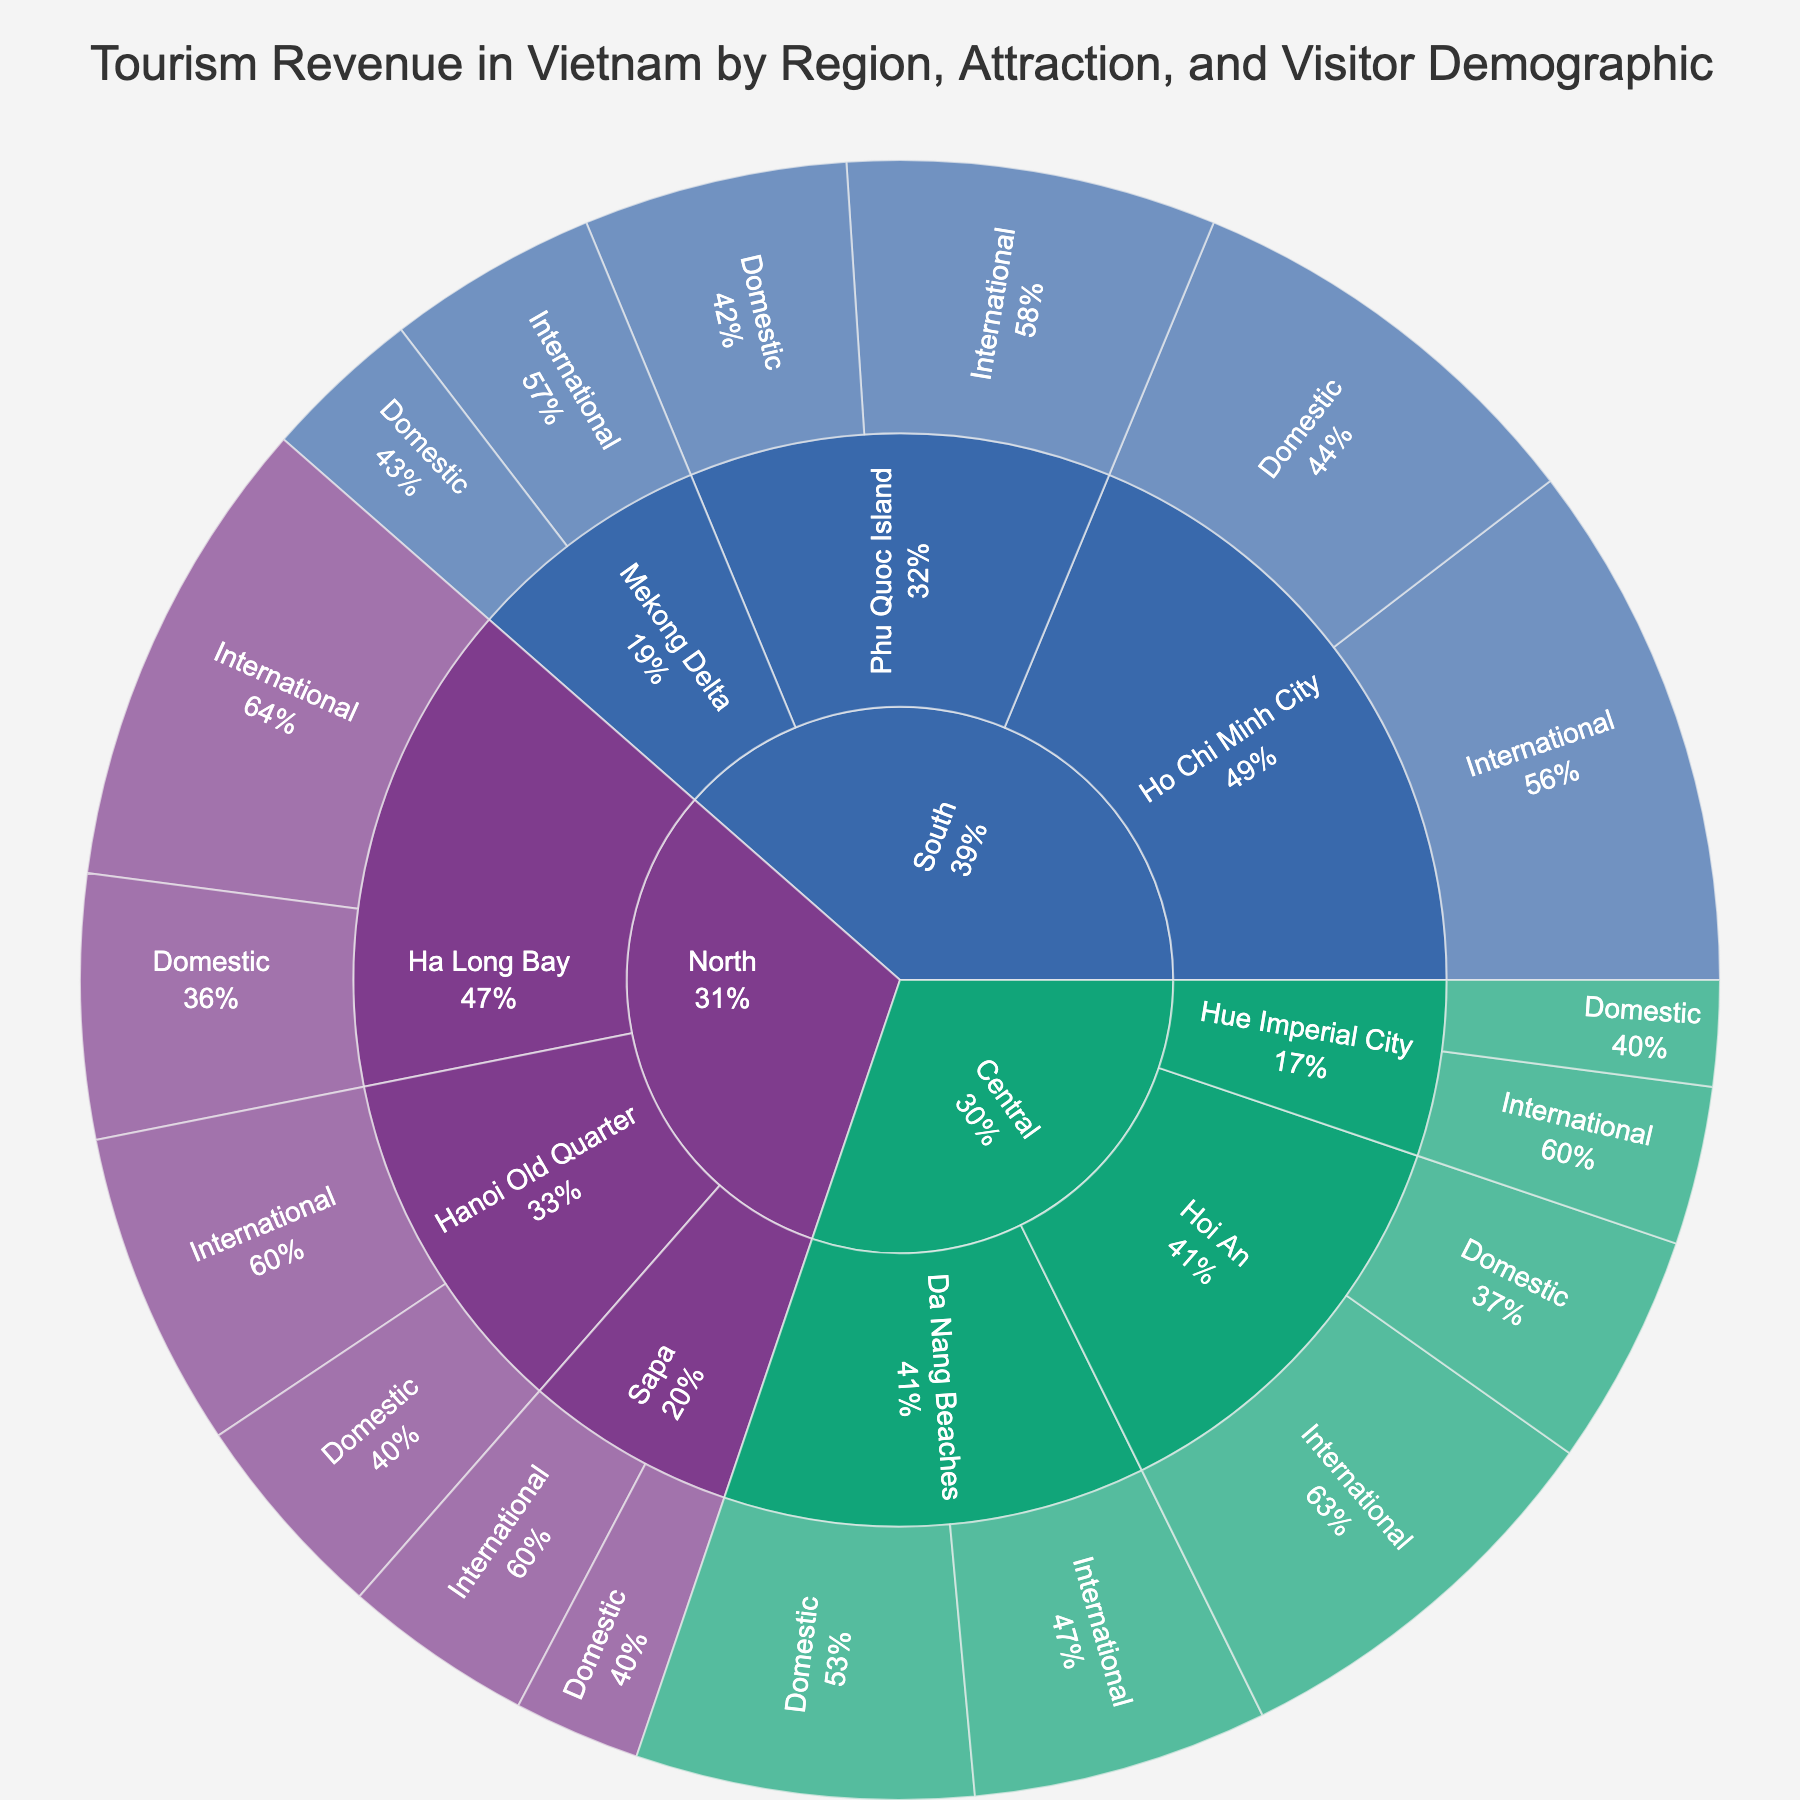what is the total tourism revenue for the North region? Calculate the total revenue for the North region by summing up the revenue from all attractions (International and Domestic visitors) in the North: $450,000,000 + $250,000,000 + $180,000,000 + $120,000,000 + $300,000,000 + $200,000,000 = $1,500,000,000
Answer: $1.5 billion which attraction in the Central region generates the highest revenue? Identify the attraction in the Central region with the highest combined revenue from both International and Domestic visitors. Hoi An has $380,000,000 (International) + $220,000,000 (Domestic) combined, Da Nang Beaches has $280,000,000 + $320,000,000, so Da Nang Beaches generates $600,000,000, which is the highest in the Central region
Answer: Da Nang Beaches How does the revenue from International visitors compare between Phu Quoc Island and Hanoi Old Quarter? Compare the revenue from International visitors for both attractions: Phu Quoc Island earns $350,000,000 while Hanoi Old Quarter earns $300,000,000, so Phu Quoc Island earns more
Answer: Phu Quoc Island Which region attracts more revenue from Domestic tourists, North or South? Sum up the domestic tourist revenue for each region: North: $250,000,000 (Ha Long Bay) + $120,000,000 (Sapa) + $200,000,000 (Hanoi Old Quarter) = $570,000,000; South: $400,000,000 (Ho Chi Minh City) + $150,000,000 (Mekong Delta) + $250,000,000 (Phu Quoc Island) = $800,000,000. South attracts more
Answer: South What percentage of total revenue at Ha Long Bay comes from International visitors? Calculate the percentage of revenue from International visitors relative to the total revenue at Ha Long Bay: $450,000,000 (International) / ($450,000,000 + $250,000,000) = 0.642857 ≈ 64.29%
Answer: 64.29% How does the revenue from Domestic visitors at Hoi An compare to Hue Imperial City? Compare the revenue from Domestic visitors: Hoi An has $220,000,000 while Hue Imperial City has $100,000,000, so Hoi An has $120,000,000 more
Answer: $120,000,000 What is the total combined tourism revenue from the top three attractions in Vietnam? Identify the top three attractions by total revenue and sum them: Ho Chi Minh City - $900,000,000, Da Nang Beaches - $600,000,000, and Ha Long Bay - $700,000,000, then sum these values: $900,000,000 + $600,000,000 + $700,000,000 = $2,200,000,000
Answer: $2.2 billion 